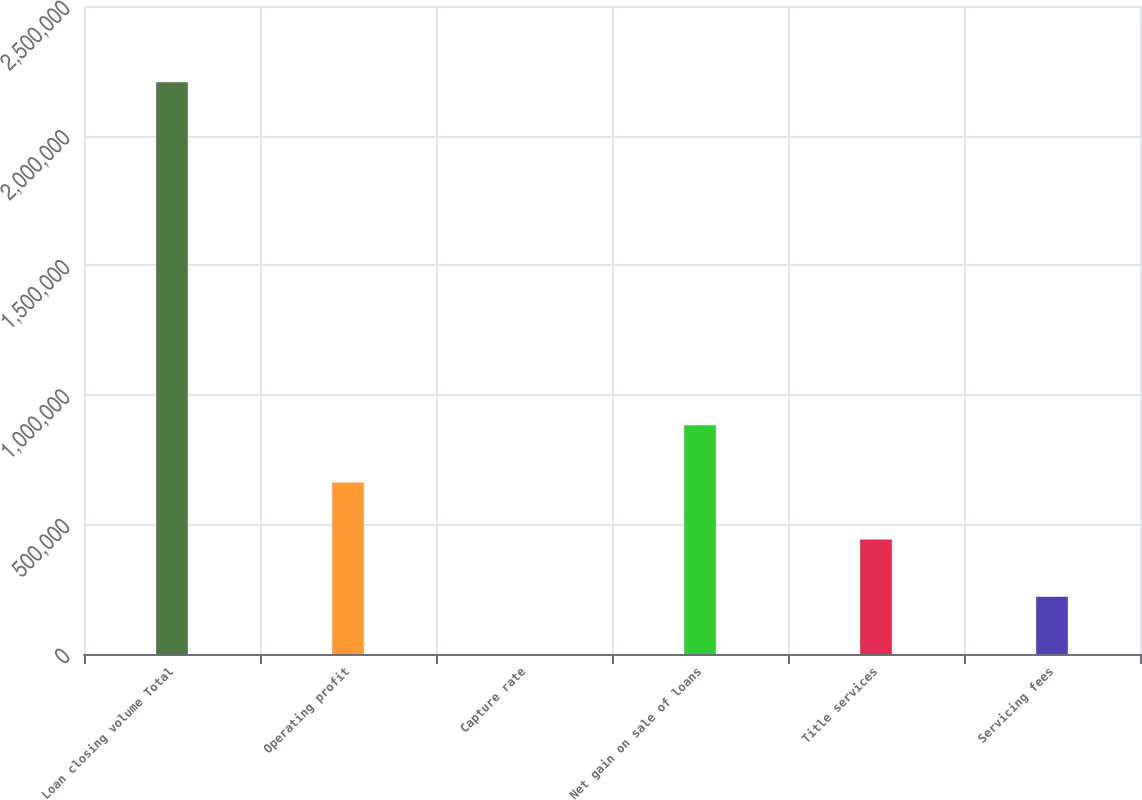Convert chart. <chart><loc_0><loc_0><loc_500><loc_500><bar_chart><fcel>Loan closing volume Total<fcel>Operating profit<fcel>Capture rate<fcel>Net gain on sale of loans<fcel>Title services<fcel>Servicing fees<nl><fcel>2.20609e+06<fcel>661888<fcel>87<fcel>882489<fcel>441288<fcel>220688<nl></chart> 